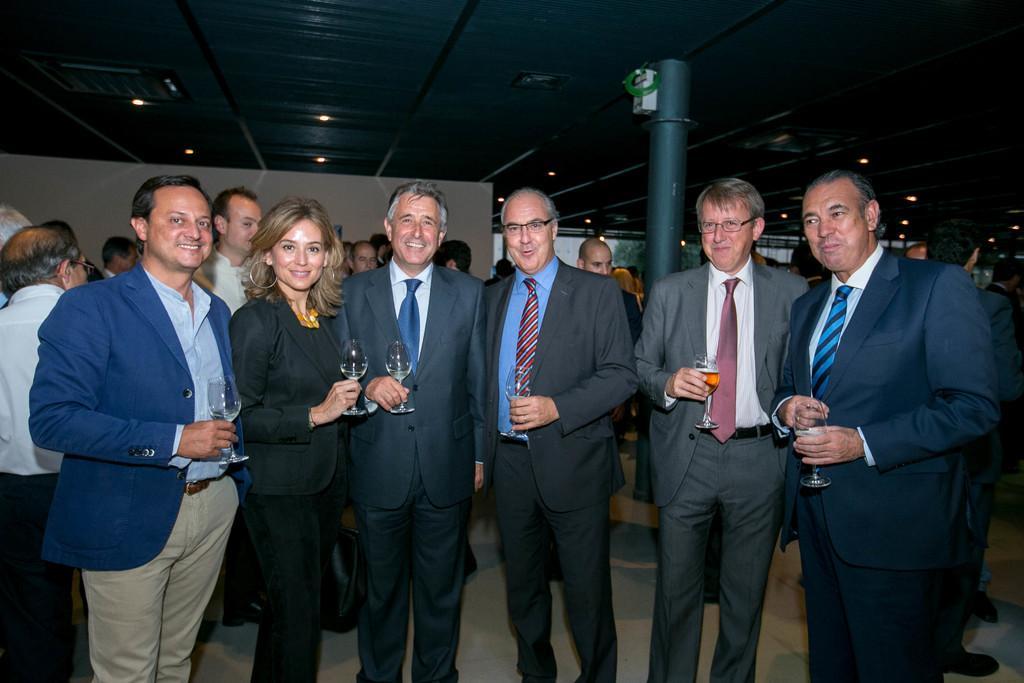Can you describe this image briefly? In the center of the image we can see people standing. They are all wearing suits and holding wine glasses. In the background there is a wall and a pillar. We can see people. At the top there are lights. 